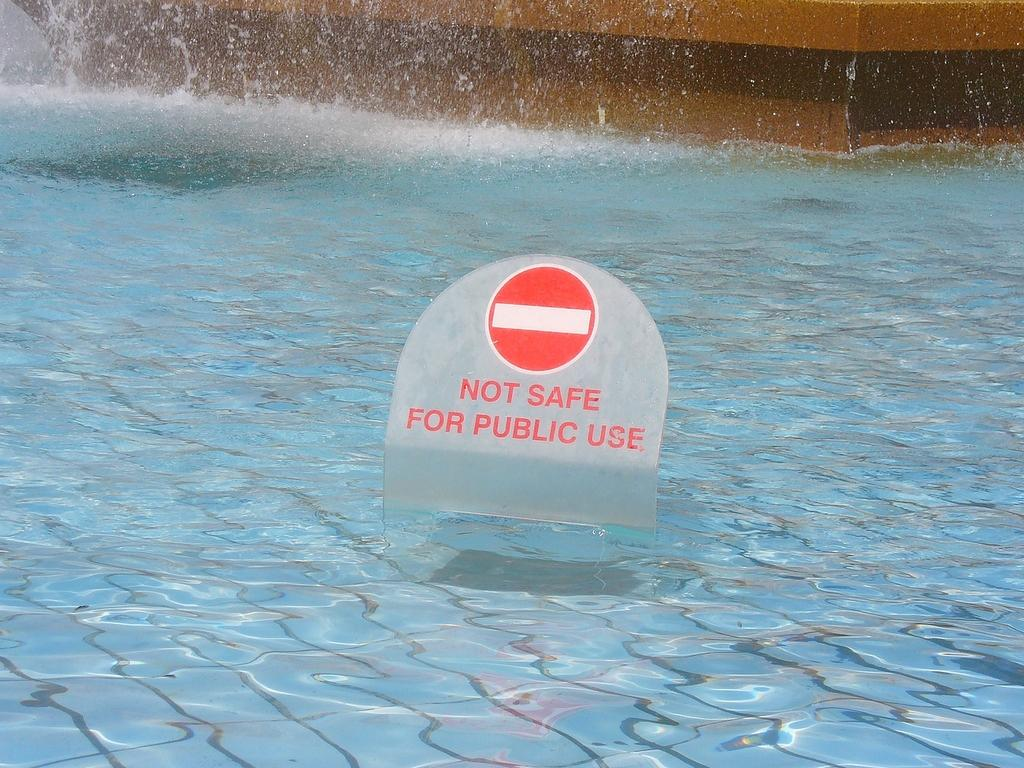What is located in the water in the image? There is a signboard in the water. What can be seen in the background of the image? There is a wall in the background of the image. What type of stone is the mailbox made of in the image? There is no mailbox present in the image, so it is not possible to determine what type of stone it might be made of. 